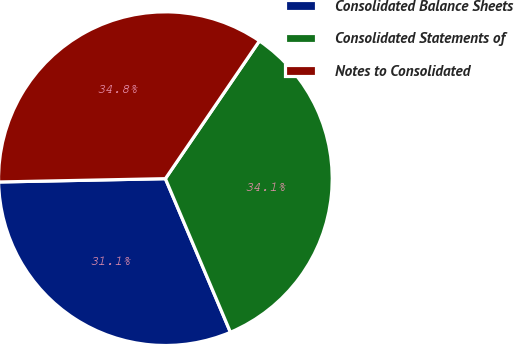<chart> <loc_0><loc_0><loc_500><loc_500><pie_chart><fcel>Consolidated Balance Sheets<fcel>Consolidated Statements of<fcel>Notes to Consolidated<nl><fcel>31.06%<fcel>34.09%<fcel>34.85%<nl></chart> 